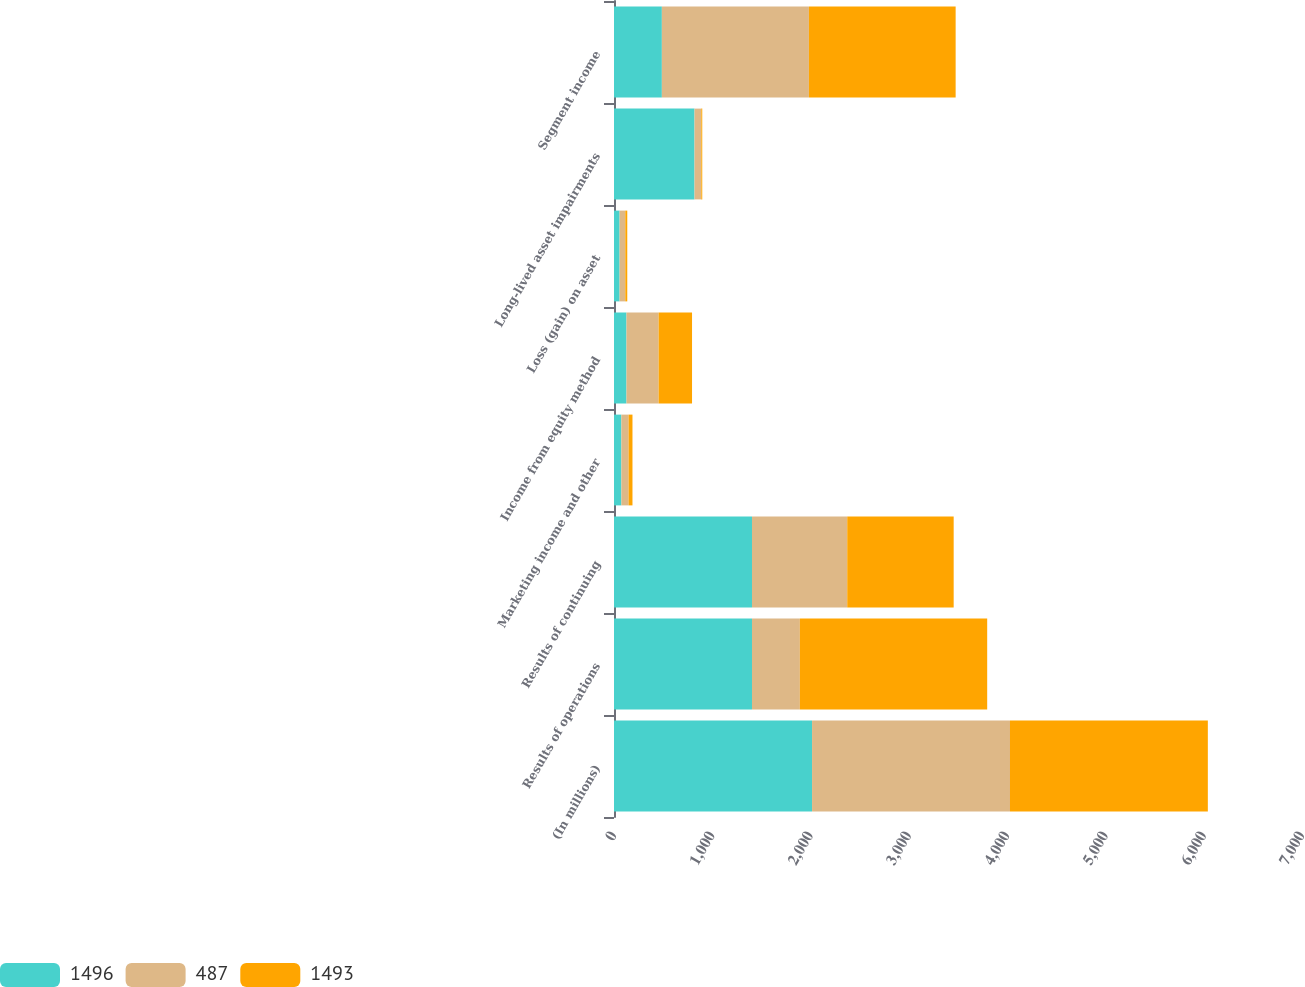Convert chart to OTSL. <chart><loc_0><loc_0><loc_500><loc_500><stacked_bar_chart><ecel><fcel>(In millions)<fcel>Results of operations<fcel>Results of continuing<fcel>Marketing income and other<fcel>Income from equity method<fcel>Loss (gain) on asset<fcel>Long-lived asset impairments<fcel>Segment income<nl><fcel>1496<fcel>2015<fcel>1404<fcel>1404<fcel>75<fcel>127<fcel>57<fcel>819<fcel>487<nl><fcel>487<fcel>2014<fcel>487<fcel>969<fcel>73<fcel>327<fcel>58<fcel>69<fcel>1496<nl><fcel>1493<fcel>2013<fcel>1906<fcel>1083<fcel>40<fcel>340<fcel>20<fcel>10<fcel>1493<nl></chart> 